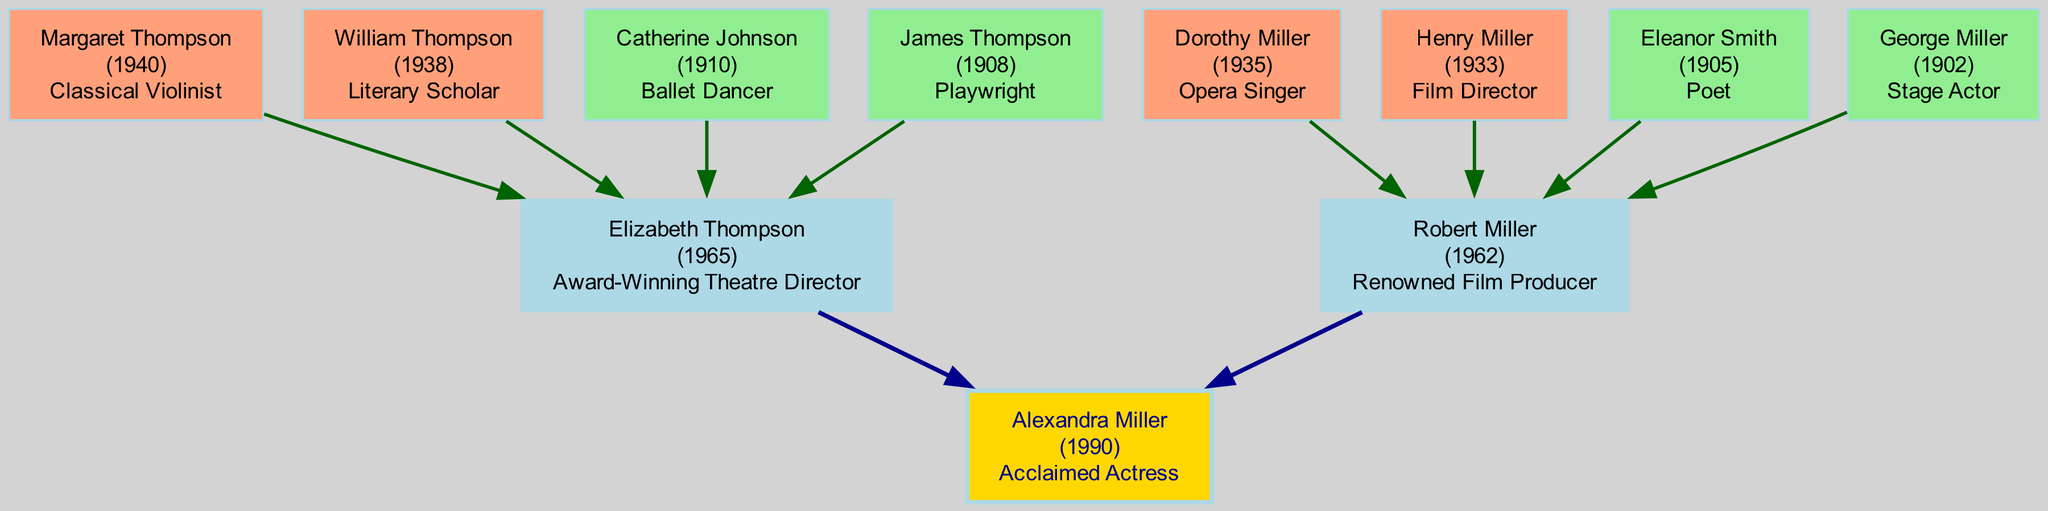What is the achievement of Alexandra Miller? The diagram specifies that Alexandra Miller is an "Acclaimed Actress." This information is directly provided in the root node of the family tree.
Answer: Acclaimed Actress How many generations are displayed in the family tree? The family tree includes one root and four generations: maternal grandparents, paternal grandparents, and great-grandparents. Adding these up results in six distinct nodes representing generations.
Answer: 6 Who is the maternal grandfather of Alexandra Miller? According to the diagram, the maternal grandfather is William Thompson, as indicated in the section detailing her ancestry.
Answer: William Thompson What achievement is noted for Henry Miller? In the diagram, Henry Miller is noted for being a "Film Director." This is clearly mentioned in his node within the family tree, identifying him as one of the actress's paternal grandparents.
Answer: Film Director Which relative has the achievement of being an opera singer? The family tree shows that Dorothy Miller, the paternal grandmother, has the achievement of being an "Opera Singer." This information is provided in her respective node in the diagram.
Answer: Opera Singer How is Catherine Johnson related to Alexandra Miller? Catherine Johnson is noted as the maternal great-grandmother of Alexandra Miller, which is evident from the generational structure laid out in the family tree diagram.
Answer: Maternal Great-Grandmother What is the birth year of Margaret Thompson? From the diagram, it is clear that Margaret Thompson was born in 1940, which is stated in her node detailing her relationship and achievement.
Answer: 1940 Which ancestor is described as a literary scholar? The diagram specifies that William Thompson, Alexandra's maternal grandfather, is recognized as a "Literary Scholar." This is mentioned in his section of the family tree, showing his notable accomplishment.
Answer: Literary Scholar Who are the parents of Alexandra Miller? The diagram identifies Alexandra's parents as Elizabeth Thompson and Robert Miller, indicating their relationship as her mother and father, respectively.
Answer: Elizabeth Thompson and Robert Miller What is the relationship between Eleanor Smith and Alexandra Miller? Eleanor Smith is depicted as the paternal great-grandmother of Alexandra Miller, indicating her position within the family lineage shown in the family tree.
Answer: Paternal Great-Grandmother 